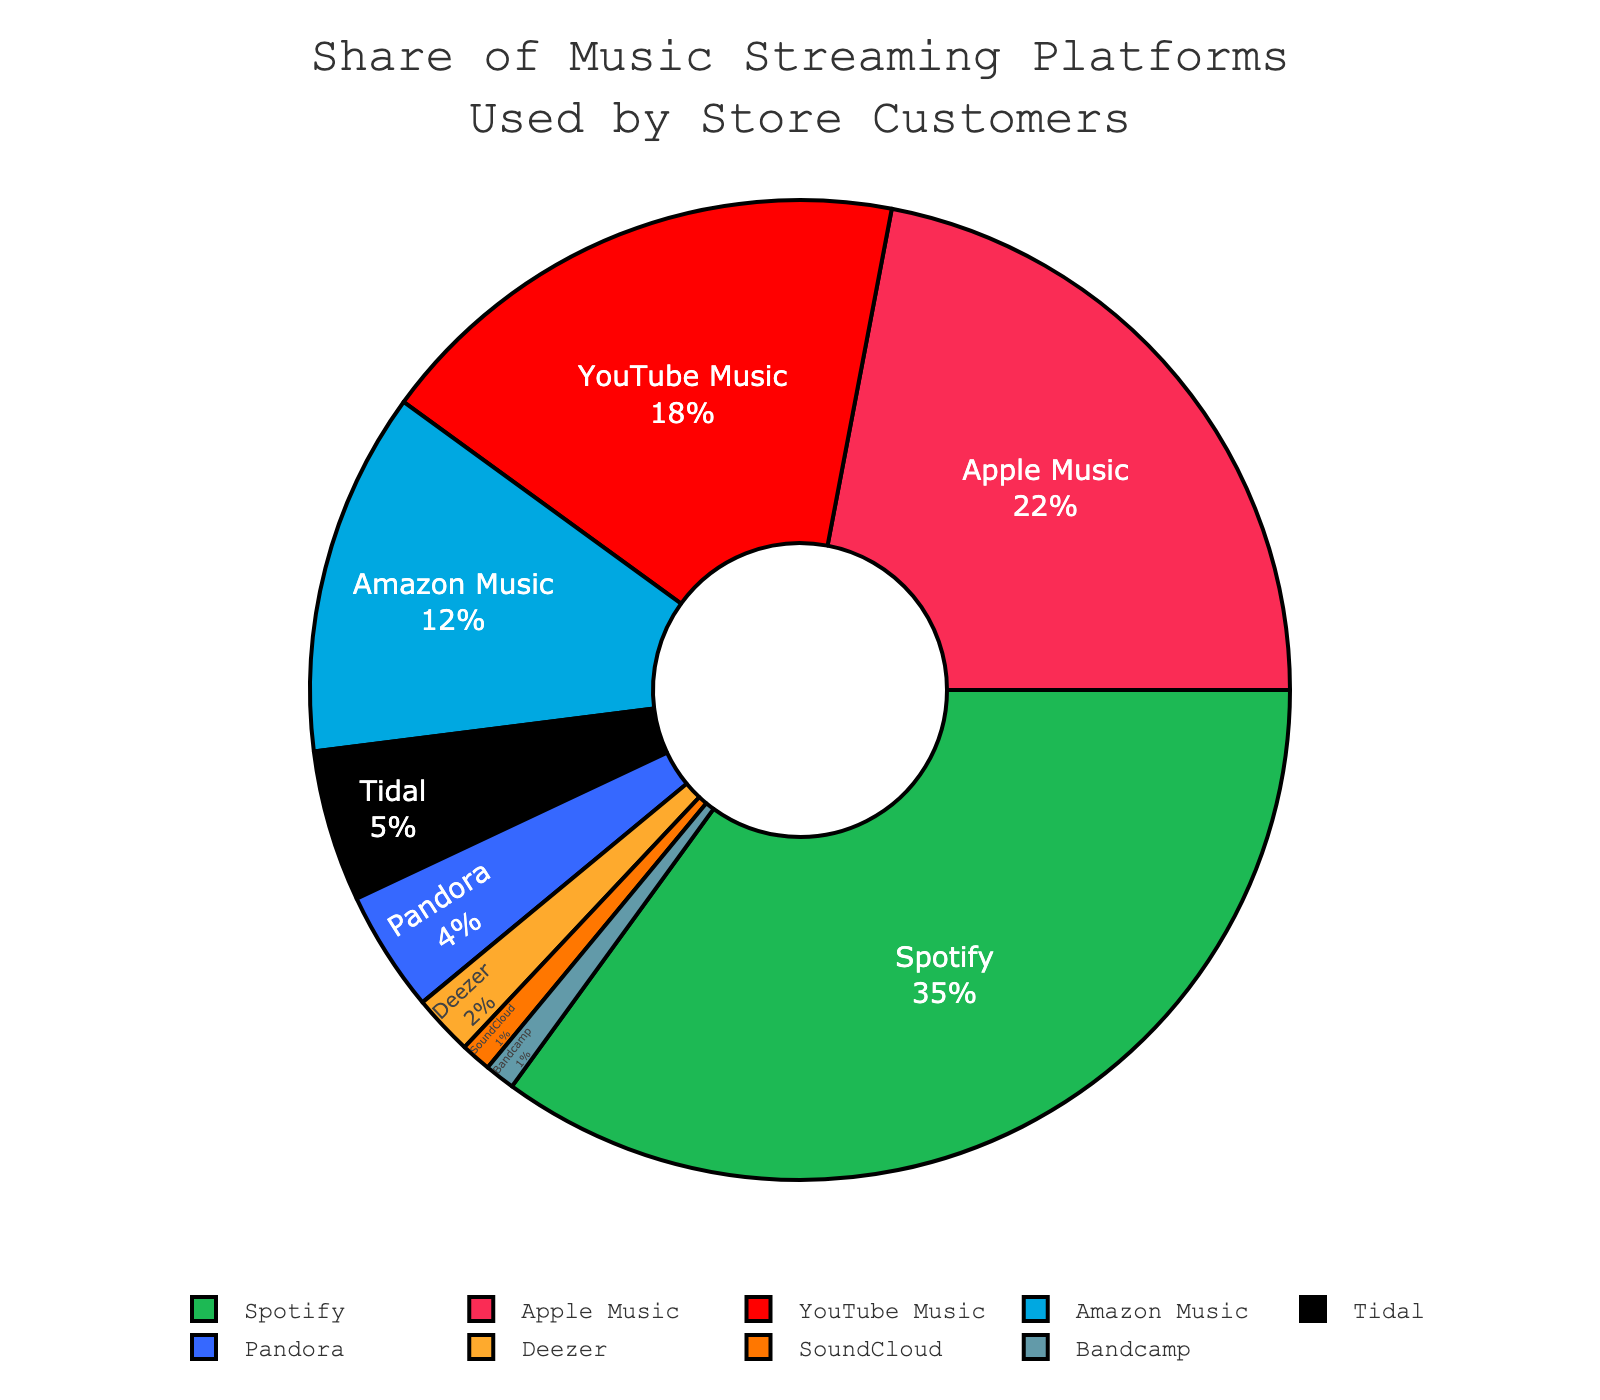What percentage of store customers use Spotify? Spotify has a 35% share of the pie chart representing the music streaming platforms used by store customers.
Answer: 35% How much greater is the percentage of store customers using Spotify compared to those using Tidal? The percentage of Spotify users is 35%, and Tidal users are 5%. The difference is 35% - 5% = 30%.
Answer: 30% Which platform has the smallest share among store customers? The two smallest shares are Bandcamp and SoundCloud, both having 1%.
Answer: Bandcamp and SoundCloud Is the combined share of store customers using YouTube Music and Amazon Music greater than the share using Spotify? YouTube Music has 18% and Amazon Music has 12%. Combined, this is 18% + 12% = 30%, which is less than Spotify's 35%.
Answer: No Which platform has a higher percentage of store customers, Apple Music or Amazon Music? Apple Music has a 22% share whereas Amazon Music has a 12% share.
Answer: Apple Music How does the percentage of customers using Apple Music compare to those using Pandora? Apple Music has 22% and Pandora has 4%. The difference is 22% - 4% = 18%.
Answer: Apple Music What is the total share of store customers using platforms other than Spotify? The total share of all platforms is 100%. Subtract Spotify's 35% to find the share of other platforms: 100% - 35% = 65%.
Answer: 65% What is the sum of the percentages for Apple Music, YouTube Music, and Amazon Music? Apple Music is 22%, YouTube Music is 18%, and Amazon Music is 12%. The sum is 22% + 18% + 12% = 52%.
Answer: 52% Which platforms together make up a quarter of the total share? Combining Amazon Music (12%) and YouTube Music (18%) gives 12% + 18% = 30%, which is slightly above one quarter (25%). None exactly make a quarter.
Answer: None exactly What is the most common visual element indicating a 35% share in this chart? The largest sector of the pie chart, colored in green, represents the 35% share held by Spotify.
Answer: Green sector representing Spotify 